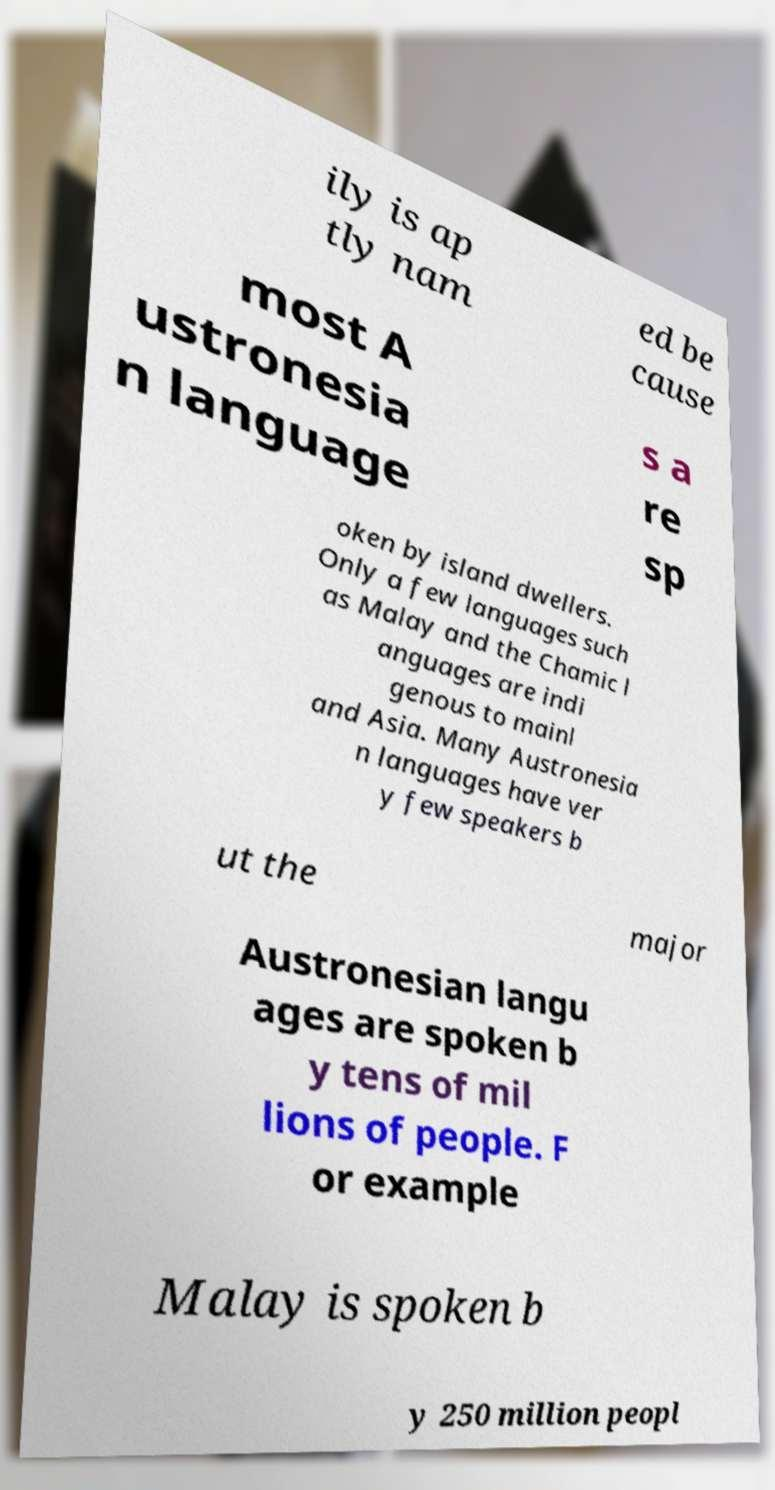Please read and relay the text visible in this image. What does it say? ily is ap tly nam ed be cause most A ustronesia n language s a re sp oken by island dwellers. Only a few languages such as Malay and the Chamic l anguages are indi genous to mainl and Asia. Many Austronesia n languages have ver y few speakers b ut the major Austronesian langu ages are spoken b y tens of mil lions of people. F or example Malay is spoken b y 250 million peopl 